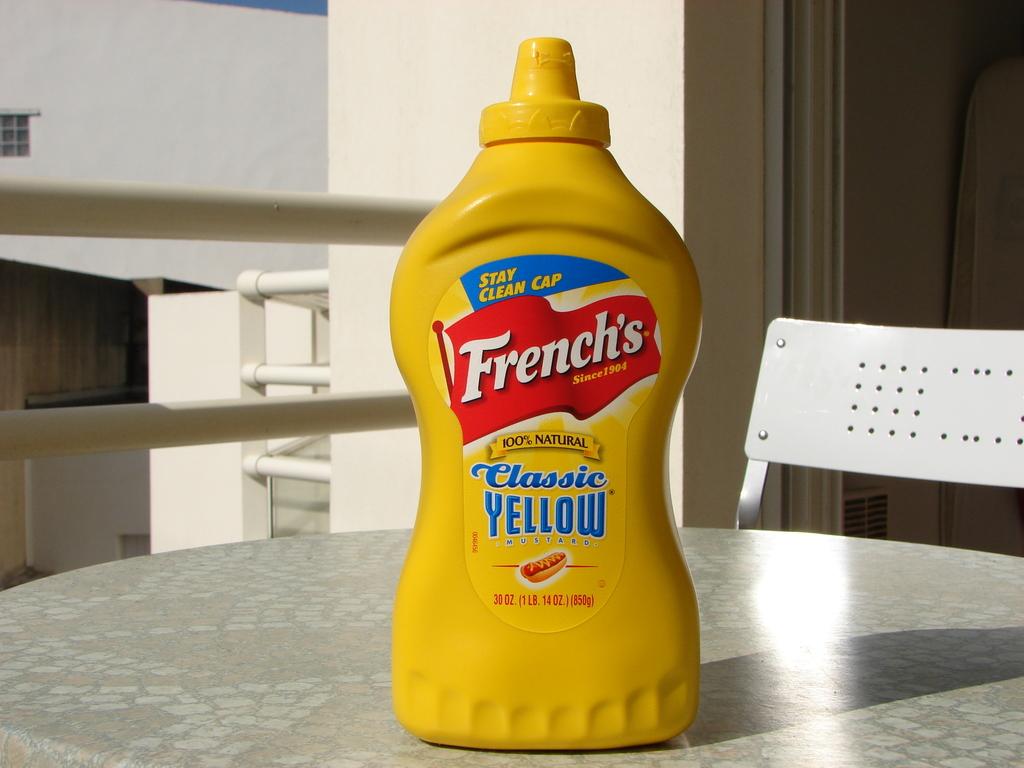Who makes this classic yellow mustard?
Give a very brief answer. French's. What color is this mustard?
Your response must be concise. Yellow. 